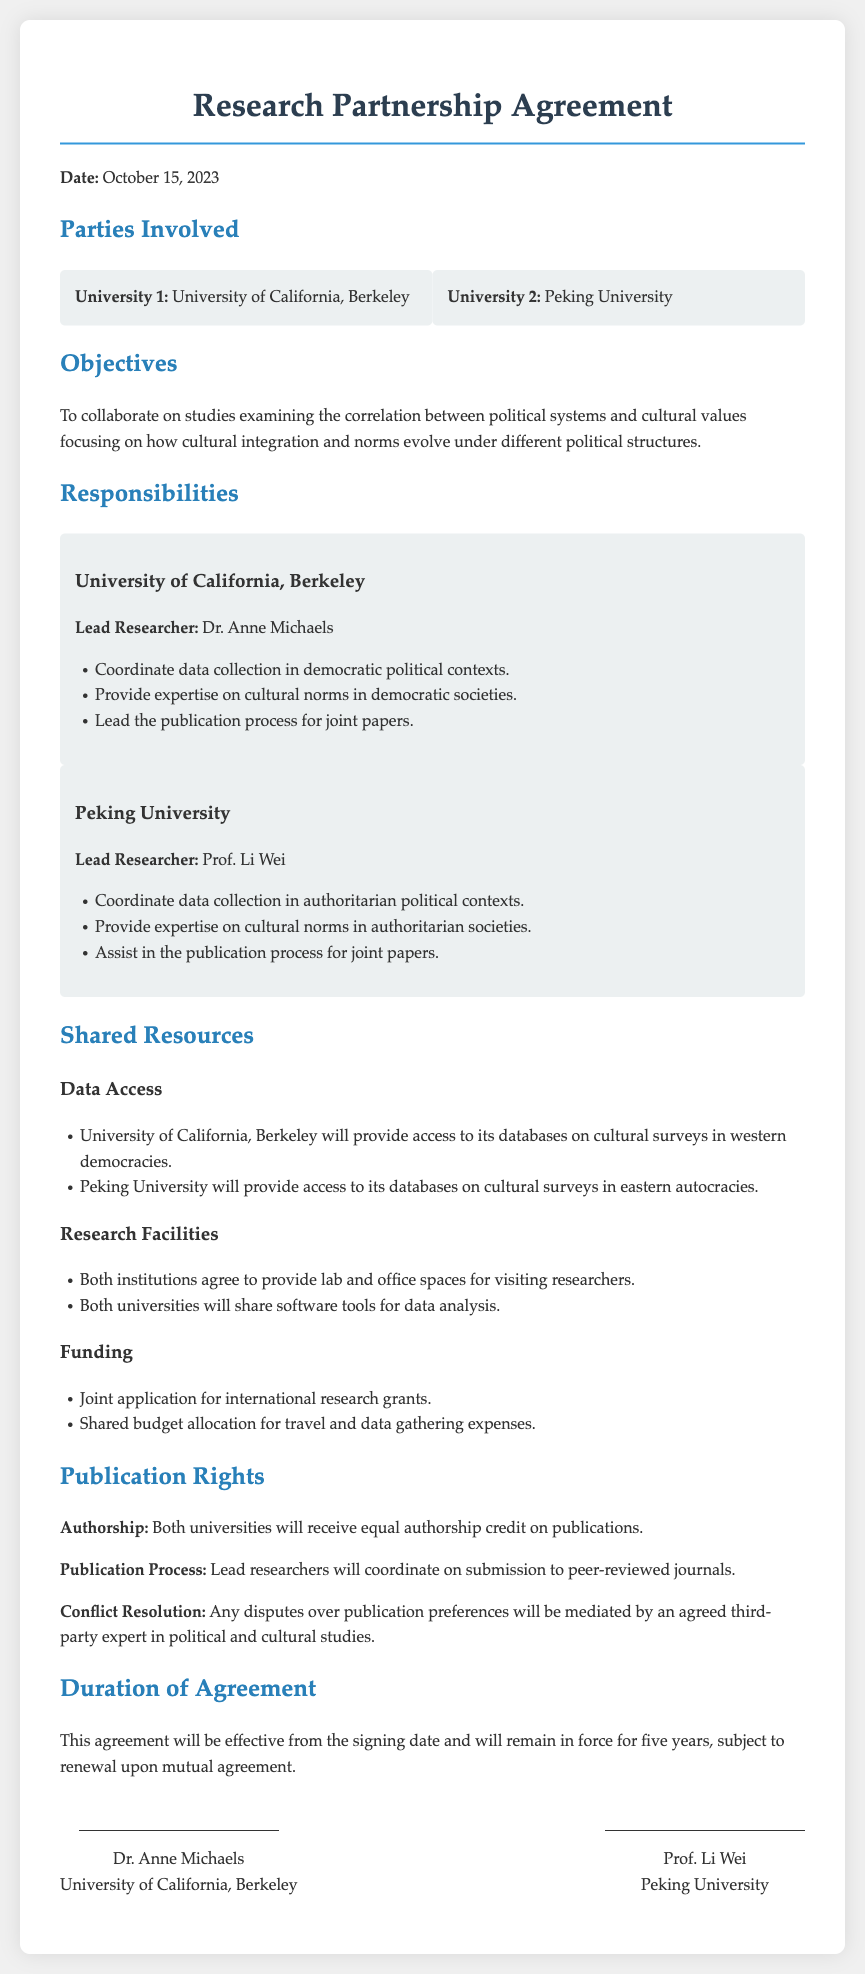What date was the agreement signed? The document specifies the signing date as October 15, 2023.
Answer: October 15, 2023 Who is the lead researcher from University of California, Berkeley? The document states that Dr. Anne Michaels is the lead researcher for this university.
Answer: Dr. Anne Michaels What is the primary objective of the partnership? The stated objective is to collaborate on studies examining the correlation between political systems and cultural values.
Answer: To collaborate on studies examining the correlation between political systems and cultural values How long will this agreement be in effect? The document indicates that the agreement will remain in force for five years.
Answer: Five years What type of publication rights do both universities have? The agreement specifies that both universities will receive equal authorship credit on publications.
Answer: Equal authorship credit What are the shared facilities provided by both universities? The document mentions that both institutions will provide lab and office spaces for visiting researchers.
Answer: Lab and office spaces Who is the lead researcher from Peking University? The document identifies Prof. Li Wei as the lead researcher for Peking University.
Answer: Prof. Li Wei What will be the funding approach for the research? The document details that there will be a joint application for international research grants.
Answer: Joint application for international research grants 